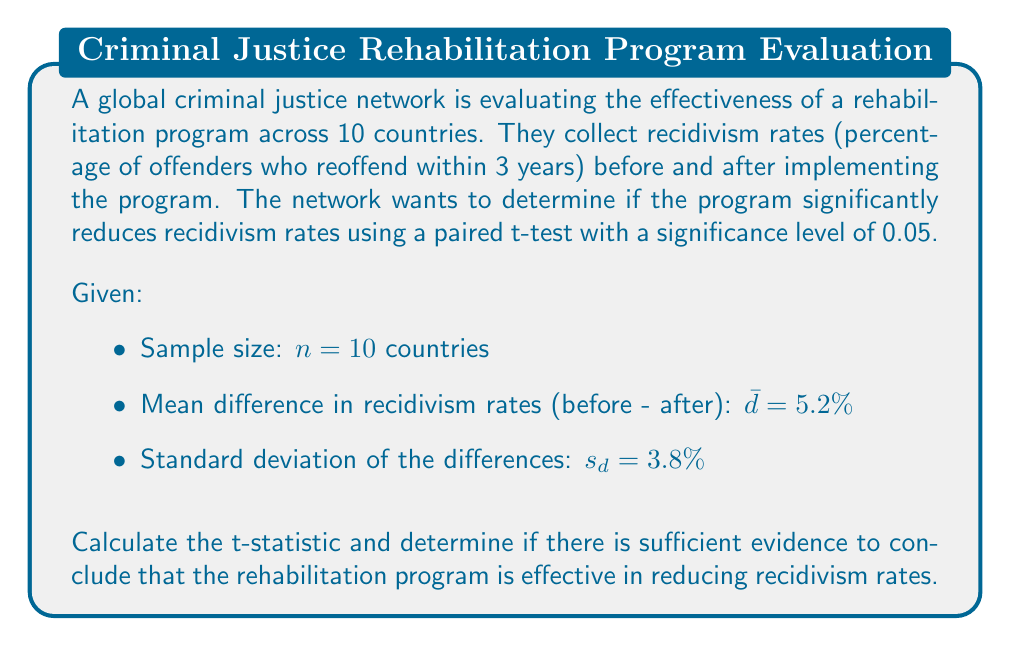Give your solution to this math problem. To evaluate the effectiveness of the rehabilitation program, we will use a paired t-test. The null hypothesis is that the mean difference in recidivism rates is zero, while the alternative hypothesis is that the mean difference is greater than zero (indicating a reduction in recidivism).

Step 1: State the hypotheses
$H_0: \mu_d = 0$ (The program has no effect on recidivism rates)
$H_a: \mu_d > 0$ (The program reduces recidivism rates)

Step 2: Calculate the t-statistic
The formula for the t-statistic in a paired t-test is:

$$ t = \frac{\bar{d}}{s_d / \sqrt{n}} $$

Where:
$\bar{d}$ = mean difference
$s_d$ = standard deviation of the differences
$n$ = sample size

Substituting the given values:

$$ t = \frac{5.2}{3.8 / \sqrt{10}} = \frac{5.2}{1.202} = 4.326 $$

Step 3: Determine the critical value
For a one-tailed test with $\alpha = 0.05$ and $df = n - 1 = 9$, the critical t-value is approximately 1.833.

Step 4: Compare the t-statistic to the critical value
Since $4.326 > 1.833$, we reject the null hypothesis.

Step 5: Calculate the p-value
Using a t-distribution calculator or table, we find that the p-value for $t = 4.326$ with $df = 9$ is approximately 0.0010.

Step 6: Interpret the results
Since the p-value (0.0010) is less than the significance level (0.05), we reject the null hypothesis. There is strong evidence to suggest that the rehabilitation program is effective in reducing recidivism rates.
Answer: The t-statistic is 4.326. Since this value is greater than the critical value of 1.833 and the p-value (0.0010) is less than the significance level (0.05), we reject the null hypothesis. There is sufficient evidence to conclude that the rehabilitation program is effective in reducing recidivism rates. 